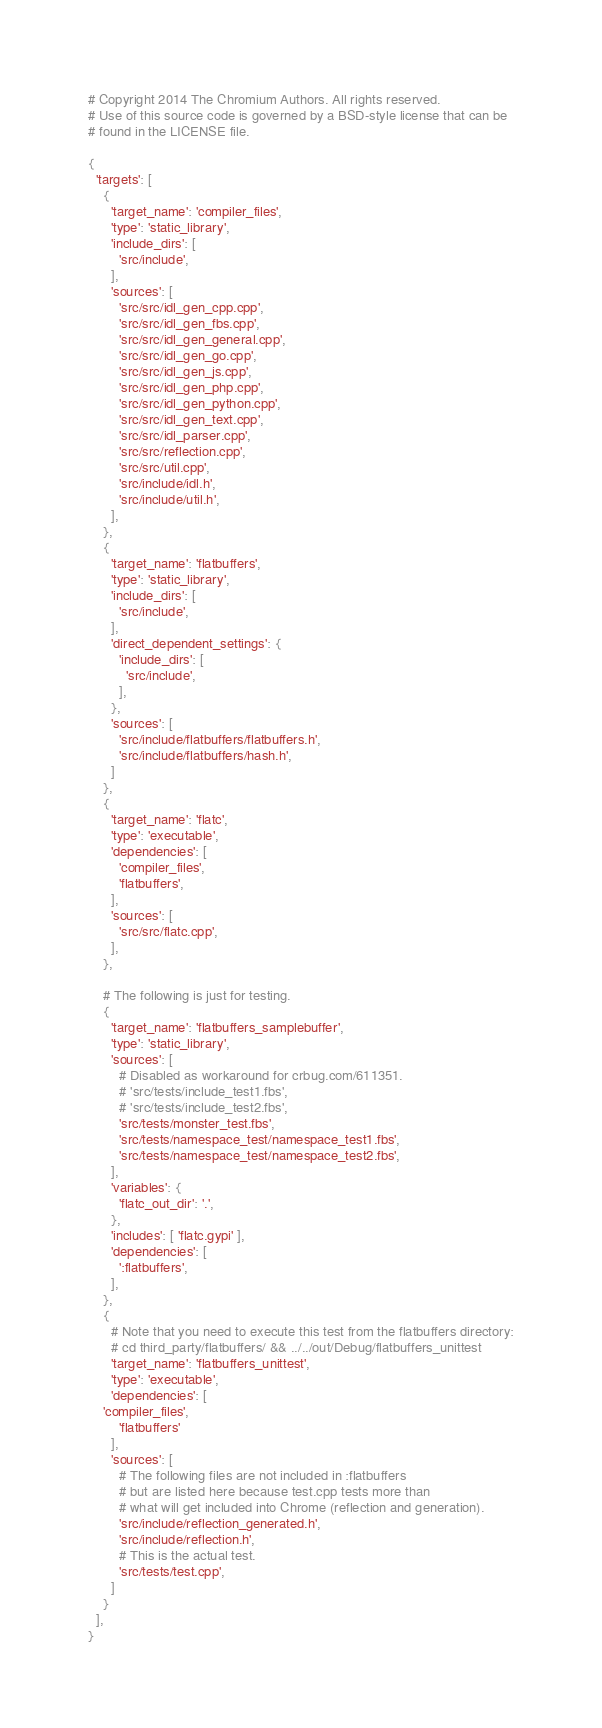Convert code to text. <code><loc_0><loc_0><loc_500><loc_500><_Python_># Copyright 2014 The Chromium Authors. All rights reserved.
# Use of this source code is governed by a BSD-style license that can be
# found in the LICENSE file.

{
  'targets': [
    {
      'target_name': 'compiler_files',
      'type': 'static_library',
      'include_dirs': [
        'src/include',
      ],
      'sources': [
        'src/src/idl_gen_cpp.cpp',
        'src/src/idl_gen_fbs.cpp',
        'src/src/idl_gen_general.cpp',
        'src/src/idl_gen_go.cpp',
        'src/src/idl_gen_js.cpp',
        'src/src/idl_gen_php.cpp',
        'src/src/idl_gen_python.cpp',
        'src/src/idl_gen_text.cpp',
        'src/src/idl_parser.cpp',
        'src/src/reflection.cpp',
        'src/src/util.cpp',
        'src/include/idl.h',
        'src/include/util.h',
      ],
    },
    {
      'target_name': 'flatbuffers',
      'type': 'static_library',
      'include_dirs': [
        'src/include',
      ],
      'direct_dependent_settings': {
        'include_dirs': [
          'src/include',
        ],
      },
      'sources': [
        'src/include/flatbuffers/flatbuffers.h',
        'src/include/flatbuffers/hash.h',
      ]
    },
    {
      'target_name': 'flatc',
      'type': 'executable',
      'dependencies': [
        'compiler_files',
        'flatbuffers',
      ],
      'sources': [
        'src/src/flatc.cpp',
      ],
    },

    # The following is just for testing.
    {
      'target_name': 'flatbuffers_samplebuffer',
      'type': 'static_library',
      'sources': [
        # Disabled as workaround for crbug.com/611351.
        # 'src/tests/include_test1.fbs',
        # 'src/tests/include_test2.fbs',
        'src/tests/monster_test.fbs',
        'src/tests/namespace_test/namespace_test1.fbs',
        'src/tests/namespace_test/namespace_test2.fbs',
      ],
      'variables': {
        'flatc_out_dir': '.',
      },
      'includes': [ 'flatc.gypi' ],
      'dependencies': [
        ':flatbuffers',
      ],
    },
    {
      # Note that you need to execute this test from the flatbuffers directory:
      # cd third_party/flatbuffers/ && ../../out/Debug/flatbuffers_unittest
      'target_name': 'flatbuffers_unittest',
      'type': 'executable',
      'dependencies': [
	'compiler_files',
        'flatbuffers'
      ],
      'sources': [
        # The following files are not included in :flatbuffers
        # but are listed here because test.cpp tests more than
        # what will get included into Chrome (reflection and generation).
        'src/include/reflection_generated.h',
        'src/include/reflection.h',
        # This is the actual test.
        'src/tests/test.cpp',
      ]
    }
  ],
}
</code> 